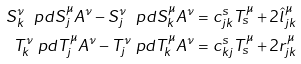Convert formula to latex. <formula><loc_0><loc_0><loc_500><loc_500>S ^ { \nu } _ { k } \ p d { S ^ { \mu } _ { j } } { A ^ { \nu } } - S ^ { \nu } _ { j } \ p d { S ^ { \mu } _ { k } } { A ^ { \nu } } & = c ^ { s } _ { j k } T ^ { \mu } _ { s } + 2 \hat { l } ^ { \mu } _ { j k } \\ T ^ { \nu } _ { k } \ p d { T ^ { \mu } _ { j } } { A ^ { \nu } } - T ^ { \nu } _ { j } \ p d { T ^ { \mu } _ { k } } { A ^ { \nu } } & = c ^ { s } _ { k j } T ^ { \mu } _ { s } + 2 r ^ { \mu } _ { j k }</formula> 